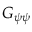<formula> <loc_0><loc_0><loc_500><loc_500>G _ { \psi \psi }</formula> 